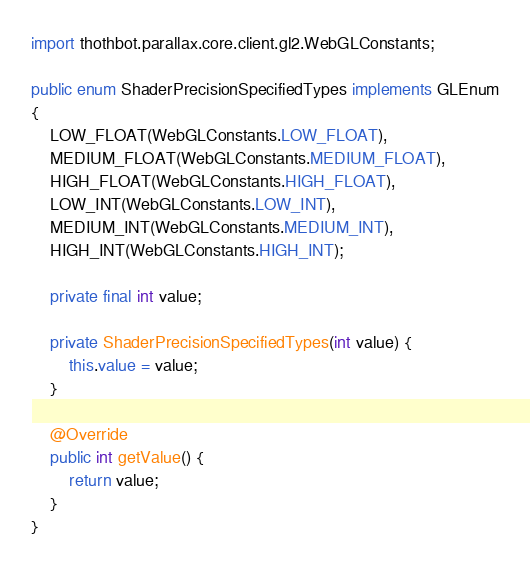<code> <loc_0><loc_0><loc_500><loc_500><_Java_>import thothbot.parallax.core.client.gl2.WebGLConstants;

public enum ShaderPrecisionSpecifiedTypes implements GLEnum
{
	LOW_FLOAT(WebGLConstants.LOW_FLOAT),
	MEDIUM_FLOAT(WebGLConstants.MEDIUM_FLOAT),
	HIGH_FLOAT(WebGLConstants.HIGH_FLOAT),
	LOW_INT(WebGLConstants.LOW_INT),
	MEDIUM_INT(WebGLConstants.MEDIUM_INT),
	HIGH_INT(WebGLConstants.HIGH_INT);

	private final int value;

	private ShaderPrecisionSpecifiedTypes(int value) {
		this.value = value;
	}

	@Override
	public int getValue() {
		return value;
	}
}
</code> 